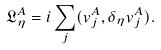Convert formula to latex. <formula><loc_0><loc_0><loc_500><loc_500>\mathfrak { L } _ { \eta } ^ { A } = i \sum _ { j } ( v _ { j } ^ { A } , \delta _ { \eta } v _ { j } ^ { A } ) .</formula> 